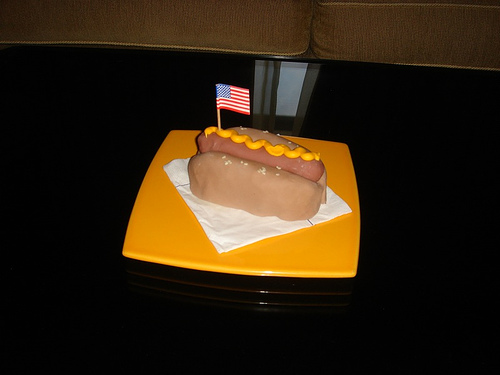What can you tell me about the presentation of the hotdog? The hotdog is placed on a clean white napkin unfolded neatly beneath it, which sits atop a vibrant orange plate. The presence of what appears to be a lit candle or a small sparkler inserted next to the flag suggests that it may be served in a festive manner, possibly in celebration of someone’s birthday or a special event. 